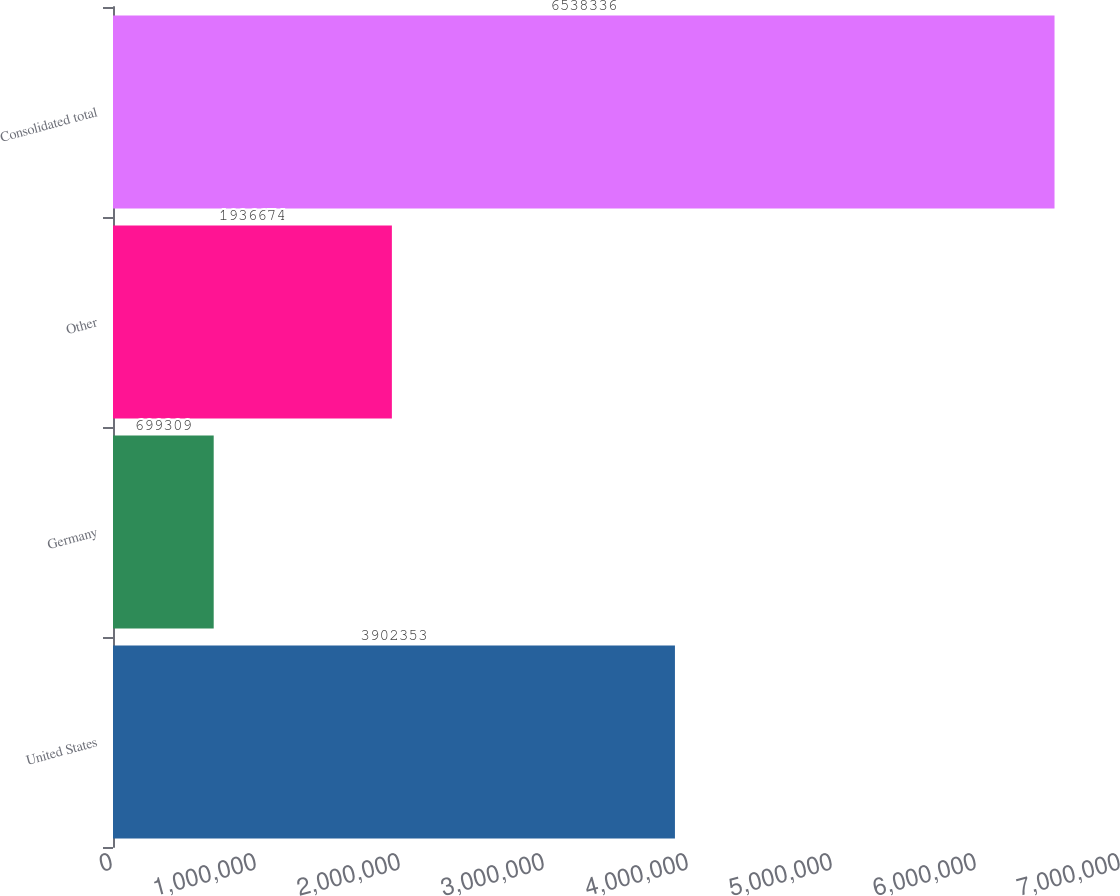<chart> <loc_0><loc_0><loc_500><loc_500><bar_chart><fcel>United States<fcel>Germany<fcel>Other<fcel>Consolidated total<nl><fcel>3.90235e+06<fcel>699309<fcel>1.93667e+06<fcel>6.53834e+06<nl></chart> 